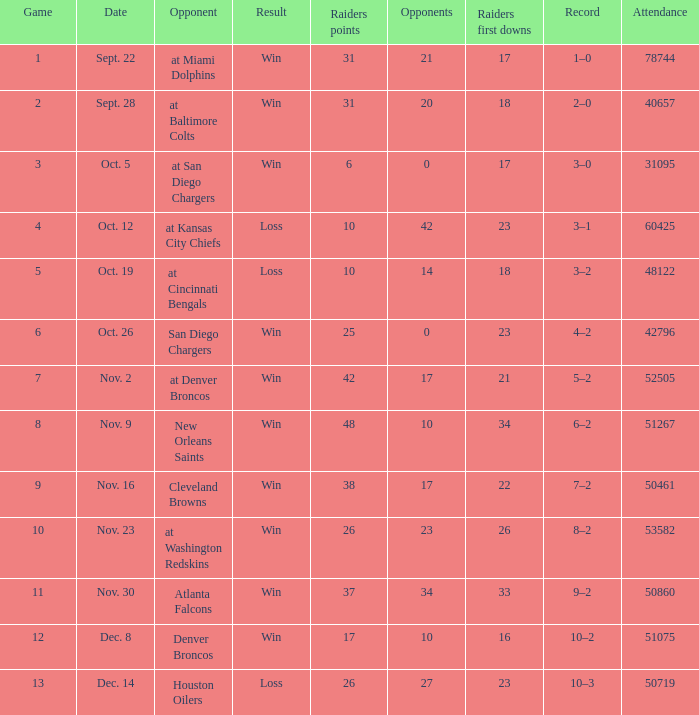In how many instances did an opponent play a single game and secure a win? 21.0. 